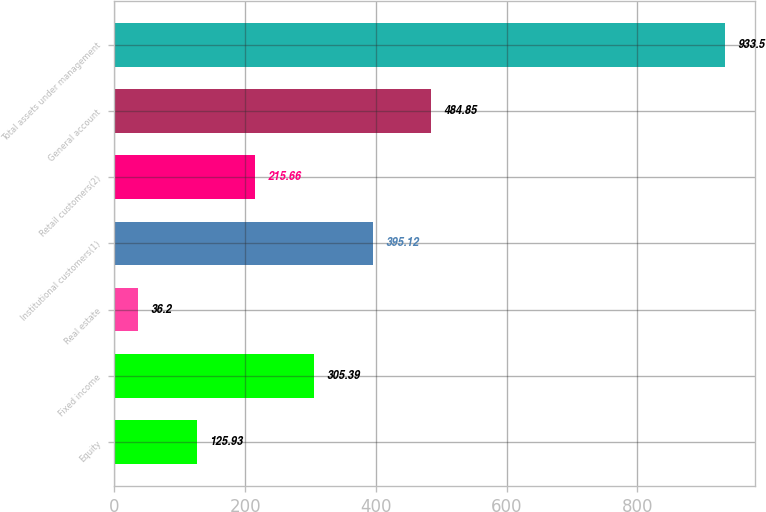Convert chart to OTSL. <chart><loc_0><loc_0><loc_500><loc_500><bar_chart><fcel>Equity<fcel>Fixed income<fcel>Real estate<fcel>Institutional customers(1)<fcel>Retail customers(2)<fcel>General account<fcel>Total assets under management<nl><fcel>125.93<fcel>305.39<fcel>36.2<fcel>395.12<fcel>215.66<fcel>484.85<fcel>933.5<nl></chart> 